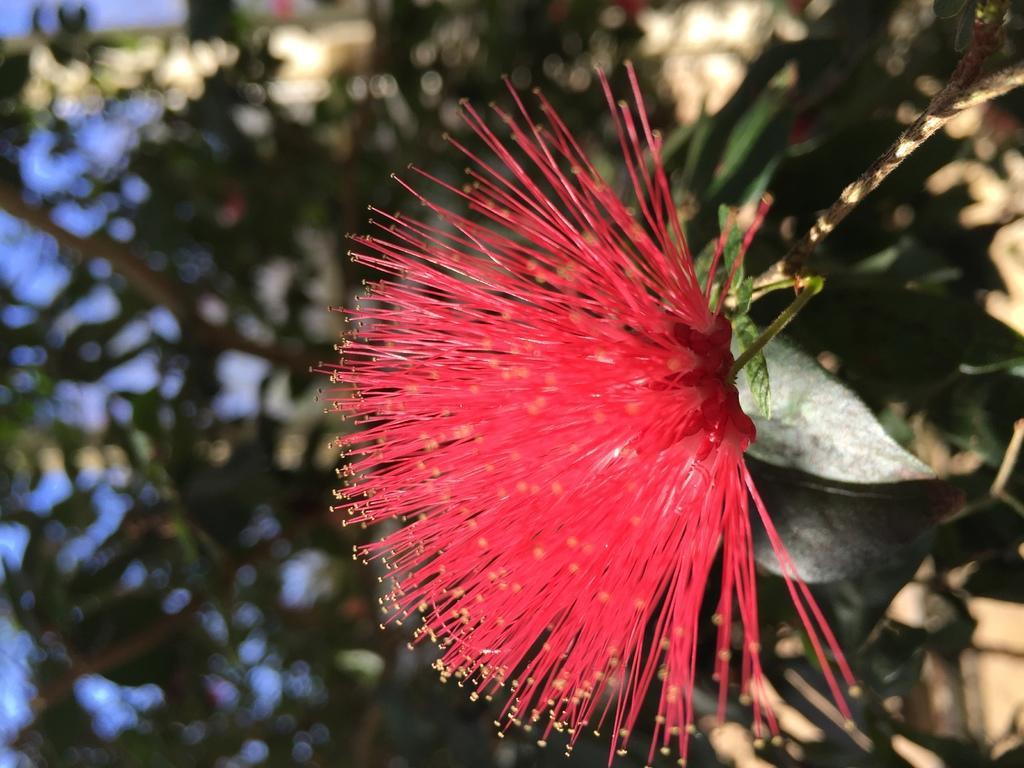What is the main subject of the picture? The main subject of the picture is a flower with a stem. What can be seen in the background of the picture? There are trees in the background of the picture. How many combs are visible in the picture? There are no combs present in the picture. What type of pigs can be seen in the picture? There are no pigs present in the picture. 